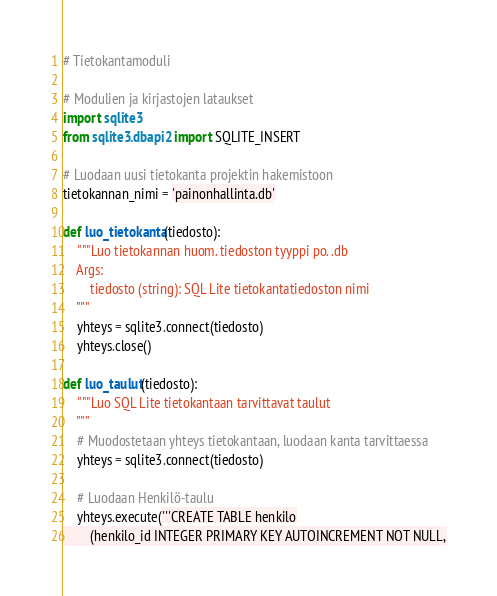<code> <loc_0><loc_0><loc_500><loc_500><_Python_># Tietokantamoduli

# Modulien ja kirjastojen lataukset
import sqlite3
from sqlite3.dbapi2 import SQLITE_INSERT

# Luodaan uusi tietokanta projektin hakemistoon
tietokannan_nimi = 'painonhallinta.db'

def luo_tietokanta(tiedosto):
    """Luo tietokannan huom. tiedoston tyyppi po. .db
    Args:
        tiedosto (string): SQL Lite tietokantatiedoston nimi
    """
    yhteys = sqlite3.connect(tiedosto)
    yhteys.close()

def luo_taulut(tiedosto):
    """Luo SQL Lite tietokantaan tarvittavat taulut
    """
    # Muodostetaan yhteys tietokantaan, luodaan kanta tarvittaessa
    yhteys = sqlite3.connect(tiedosto)

    # Luodaan Henkilö-taulu
    yhteys.execute('''CREATE TABLE henkilo
        (henkilo_id INTEGER PRIMARY KEY AUTOINCREMENT NOT NULL,</code> 